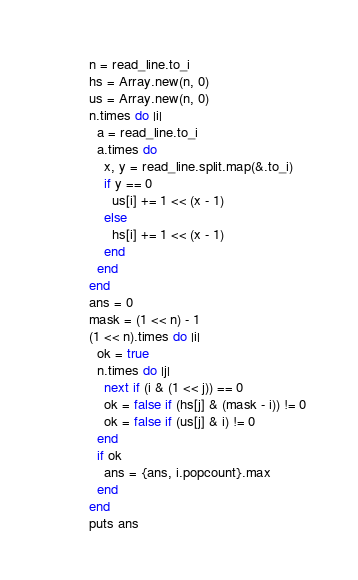Convert code to text. <code><loc_0><loc_0><loc_500><loc_500><_Crystal_>n = read_line.to_i
hs = Array.new(n, 0)
us = Array.new(n, 0)
n.times do |i|
  a = read_line.to_i
  a.times do
    x, y = read_line.split.map(&.to_i)
    if y == 0
      us[i] += 1 << (x - 1)
    else
      hs[i] += 1 << (x - 1)
    end
  end
end
ans = 0
mask = (1 << n) - 1
(1 << n).times do |i|
  ok = true
  n.times do |j|
    next if (i & (1 << j)) == 0
    ok = false if (hs[j] & (mask - i)) != 0
    ok = false if (us[j] & i) != 0
  end
  if ok
    ans = {ans, i.popcount}.max
  end
end
puts ans
</code> 